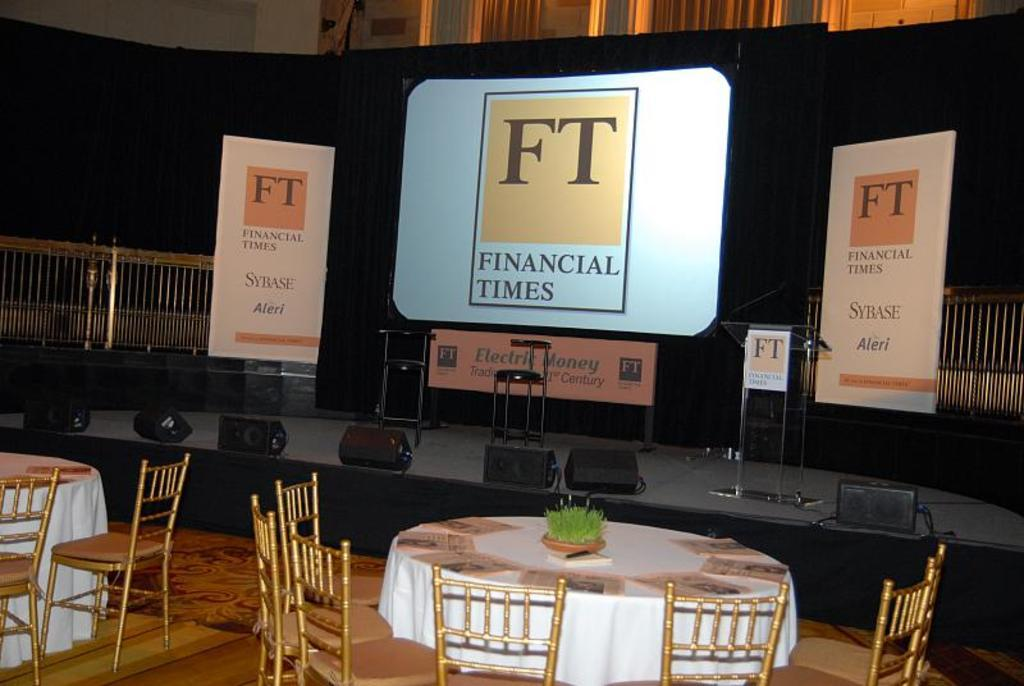<image>
Offer a succinct explanation of the picture presented. Empty tables and chairs in front of a Financial Times display on a black background. 